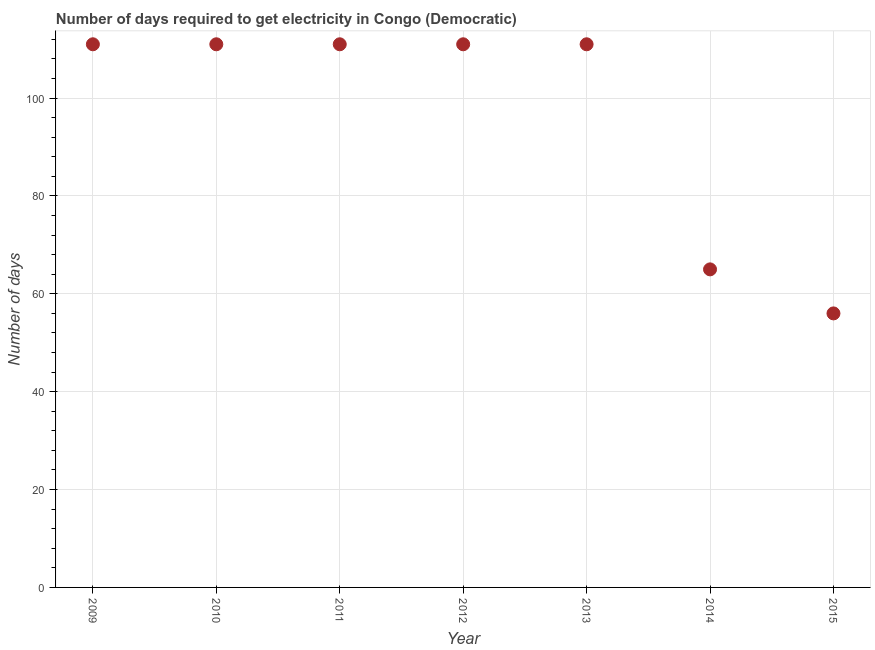What is the time to get electricity in 2014?
Keep it short and to the point. 65. Across all years, what is the maximum time to get electricity?
Keep it short and to the point. 111. Across all years, what is the minimum time to get electricity?
Provide a succinct answer. 56. In which year was the time to get electricity minimum?
Offer a terse response. 2015. What is the sum of the time to get electricity?
Provide a short and direct response. 676. What is the difference between the time to get electricity in 2009 and 2013?
Ensure brevity in your answer.  0. What is the average time to get electricity per year?
Offer a terse response. 96.57. What is the median time to get electricity?
Provide a short and direct response. 111. In how many years, is the time to get electricity greater than 108 ?
Ensure brevity in your answer.  5. Do a majority of the years between 2014 and 2013 (inclusive) have time to get electricity greater than 96 ?
Provide a succinct answer. No. What is the ratio of the time to get electricity in 2011 to that in 2015?
Keep it short and to the point. 1.98. What is the difference between the highest and the lowest time to get electricity?
Ensure brevity in your answer.  55. Does the time to get electricity monotonically increase over the years?
Offer a very short reply. No. How many dotlines are there?
Your answer should be very brief. 1. How many years are there in the graph?
Keep it short and to the point. 7. Does the graph contain grids?
Provide a succinct answer. Yes. What is the title of the graph?
Offer a very short reply. Number of days required to get electricity in Congo (Democratic). What is the label or title of the X-axis?
Make the answer very short. Year. What is the label or title of the Y-axis?
Offer a very short reply. Number of days. What is the Number of days in 2009?
Give a very brief answer. 111. What is the Number of days in 2010?
Provide a succinct answer. 111. What is the Number of days in 2011?
Keep it short and to the point. 111. What is the Number of days in 2012?
Your response must be concise. 111. What is the Number of days in 2013?
Your response must be concise. 111. What is the difference between the Number of days in 2009 and 2010?
Offer a terse response. 0. What is the difference between the Number of days in 2009 and 2014?
Your answer should be compact. 46. What is the difference between the Number of days in 2009 and 2015?
Offer a terse response. 55. What is the difference between the Number of days in 2010 and 2014?
Keep it short and to the point. 46. What is the difference between the Number of days in 2010 and 2015?
Provide a short and direct response. 55. What is the difference between the Number of days in 2011 and 2013?
Your answer should be compact. 0. What is the difference between the Number of days in 2013 and 2014?
Ensure brevity in your answer.  46. What is the ratio of the Number of days in 2009 to that in 2010?
Provide a succinct answer. 1. What is the ratio of the Number of days in 2009 to that in 2013?
Offer a terse response. 1. What is the ratio of the Number of days in 2009 to that in 2014?
Your response must be concise. 1.71. What is the ratio of the Number of days in 2009 to that in 2015?
Keep it short and to the point. 1.98. What is the ratio of the Number of days in 2010 to that in 2011?
Provide a succinct answer. 1. What is the ratio of the Number of days in 2010 to that in 2013?
Provide a short and direct response. 1. What is the ratio of the Number of days in 2010 to that in 2014?
Give a very brief answer. 1.71. What is the ratio of the Number of days in 2010 to that in 2015?
Give a very brief answer. 1.98. What is the ratio of the Number of days in 2011 to that in 2013?
Your answer should be very brief. 1. What is the ratio of the Number of days in 2011 to that in 2014?
Offer a very short reply. 1.71. What is the ratio of the Number of days in 2011 to that in 2015?
Your answer should be very brief. 1.98. What is the ratio of the Number of days in 2012 to that in 2014?
Keep it short and to the point. 1.71. What is the ratio of the Number of days in 2012 to that in 2015?
Provide a short and direct response. 1.98. What is the ratio of the Number of days in 2013 to that in 2014?
Provide a succinct answer. 1.71. What is the ratio of the Number of days in 2013 to that in 2015?
Make the answer very short. 1.98. What is the ratio of the Number of days in 2014 to that in 2015?
Offer a very short reply. 1.16. 